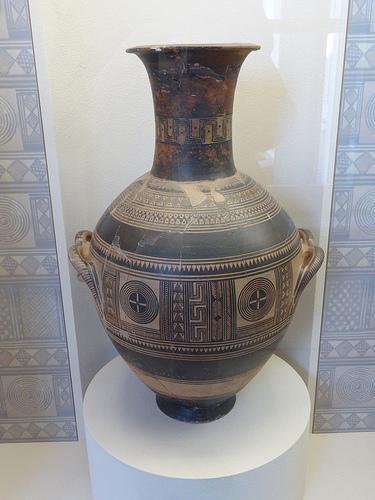How many circles do you see on the front of the vase?
Give a very brief answer. 2. 